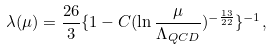<formula> <loc_0><loc_0><loc_500><loc_500>\lambda ( \mu ) = \frac { 2 6 } { 3 } \{ 1 - C ( \ln \frac { \mu } { \Lambda _ { Q C D } } ) ^ { - \frac { 1 3 } { 2 2 } } \} ^ { - 1 } ,</formula> 